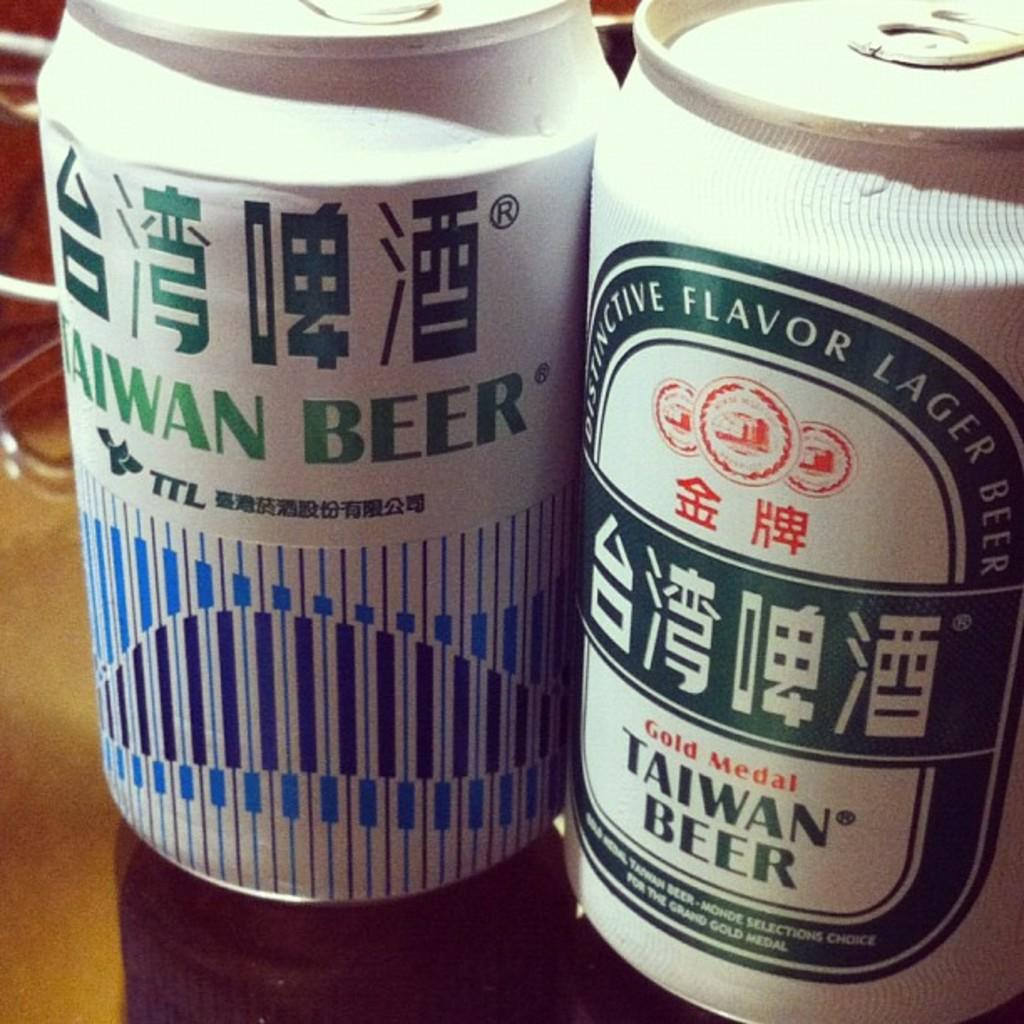<image>
Share a concise interpretation of the image provided. Two different type cans of Taiwan brand Beer. 